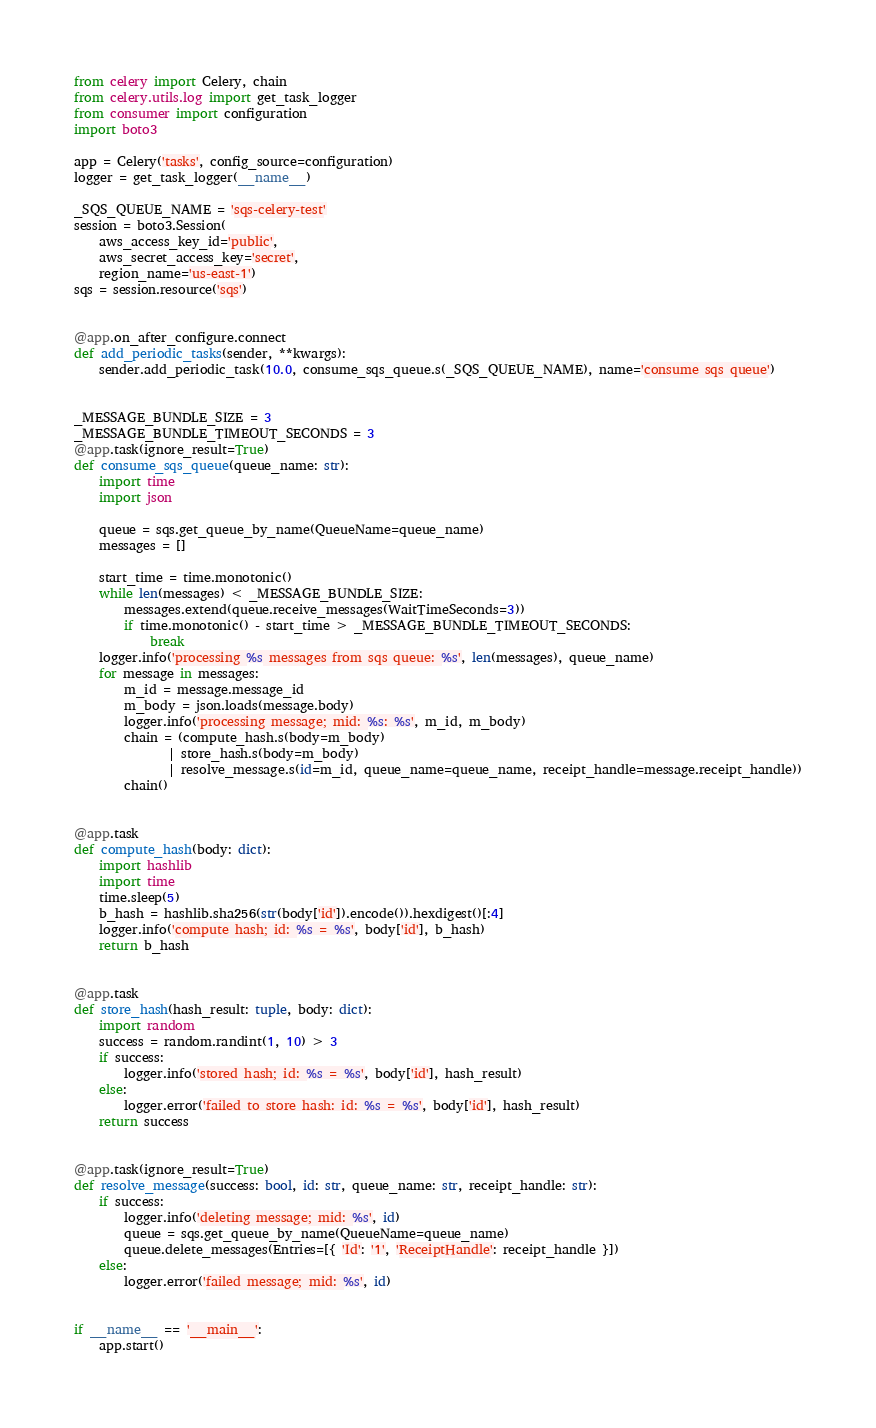<code> <loc_0><loc_0><loc_500><loc_500><_Python_>from celery import Celery, chain
from celery.utils.log import get_task_logger
from consumer import configuration
import boto3

app = Celery('tasks', config_source=configuration)
logger = get_task_logger(__name__)

_SQS_QUEUE_NAME = 'sqs-celery-test'
session = boto3.Session(
    aws_access_key_id='public',
    aws_secret_access_key='secret',
    region_name='us-east-1')
sqs = session.resource('sqs')


@app.on_after_configure.connect
def add_periodic_tasks(sender, **kwargs):
    sender.add_periodic_task(10.0, consume_sqs_queue.s(_SQS_QUEUE_NAME), name='consume sqs queue')


_MESSAGE_BUNDLE_SIZE = 3
_MESSAGE_BUNDLE_TIMEOUT_SECONDS = 3
@app.task(ignore_result=True)
def consume_sqs_queue(queue_name: str):
    import time
    import json

    queue = sqs.get_queue_by_name(QueueName=queue_name)
    messages = []

    start_time = time.monotonic()
    while len(messages) < _MESSAGE_BUNDLE_SIZE:
        messages.extend(queue.receive_messages(WaitTimeSeconds=3))
        if time.monotonic() - start_time > _MESSAGE_BUNDLE_TIMEOUT_SECONDS:
            break
    logger.info('processing %s messages from sqs queue: %s', len(messages), queue_name)
    for message in messages:
        m_id = message.message_id
        m_body = json.loads(message.body)
        logger.info('processing message; mid: %s: %s', m_id, m_body)
        chain = (compute_hash.s(body=m_body)
               | store_hash.s(body=m_body)
               | resolve_message.s(id=m_id, queue_name=queue_name, receipt_handle=message.receipt_handle))
        chain()


@app.task
def compute_hash(body: dict):
    import hashlib
    import time
    time.sleep(5)
    b_hash = hashlib.sha256(str(body['id']).encode()).hexdigest()[:4]
    logger.info('compute hash; id: %s = %s', body['id'], b_hash)
    return b_hash


@app.task
def store_hash(hash_result: tuple, body: dict):
    import random
    success = random.randint(1, 10) > 3
    if success:
        logger.info('stored hash; id: %s = %s', body['id'], hash_result)
    else:
        logger.error('failed to store hash: id: %s = %s', body['id'], hash_result)
    return success


@app.task(ignore_result=True)
def resolve_message(success: bool, id: str, queue_name: str, receipt_handle: str):
    if success:
        logger.info('deleting message; mid: %s', id)
        queue = sqs.get_queue_by_name(QueueName=queue_name)
        queue.delete_messages(Entries=[{ 'Id': '1', 'ReceiptHandle': receipt_handle }])
    else:
        logger.error('failed message; mid: %s', id)


if __name__ == '__main__':
    app.start()</code> 